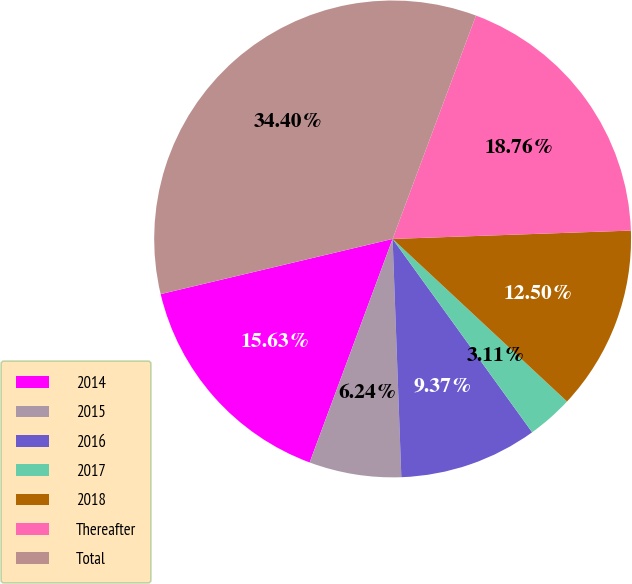Convert chart to OTSL. <chart><loc_0><loc_0><loc_500><loc_500><pie_chart><fcel>2014<fcel>2015<fcel>2016<fcel>2017<fcel>2018<fcel>Thereafter<fcel>Total<nl><fcel>15.63%<fcel>6.24%<fcel>9.37%<fcel>3.11%<fcel>12.5%<fcel>18.76%<fcel>34.41%<nl></chart> 